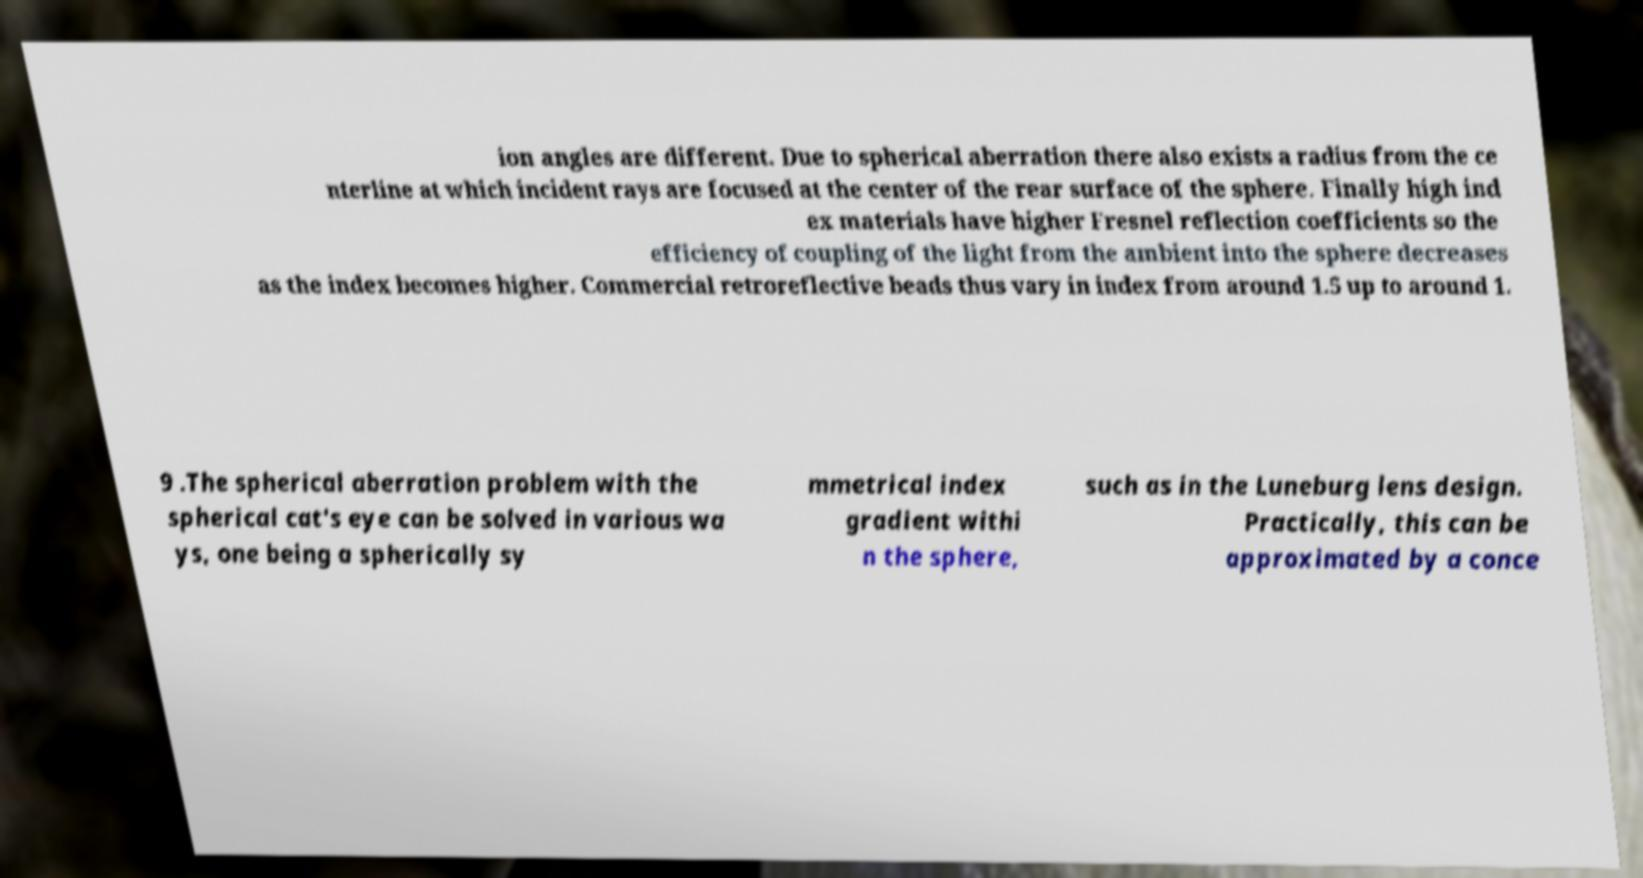Can you read and provide the text displayed in the image?This photo seems to have some interesting text. Can you extract and type it out for me? ion angles are different. Due to spherical aberration there also exists a radius from the ce nterline at which incident rays are focused at the center of the rear surface of the sphere. Finally high ind ex materials have higher Fresnel reflection coefficients so the efficiency of coupling of the light from the ambient into the sphere decreases as the index becomes higher. Commercial retroreflective beads thus vary in index from around 1.5 up to around 1. 9 .The spherical aberration problem with the spherical cat's eye can be solved in various wa ys, one being a spherically sy mmetrical index gradient withi n the sphere, such as in the Luneburg lens design. Practically, this can be approximated by a conce 